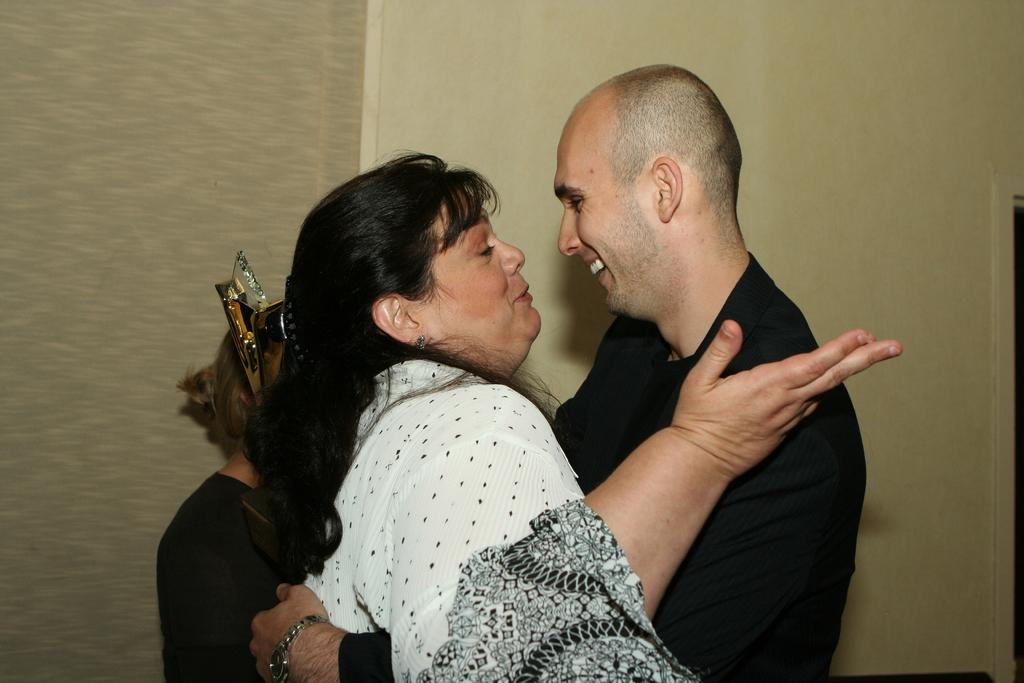How many people are in the image? There are three people in the image. What else can be seen in the image besides the people? There are objects present in the image. What is visible in the background of the image? There is a wall visible in the background of the image. Can you see any fields or open spaces in the image? There is no field or open space visible in the image; it only shows three people and objects. Are there any flies present in the image? There is no indication of any flies in the image. 